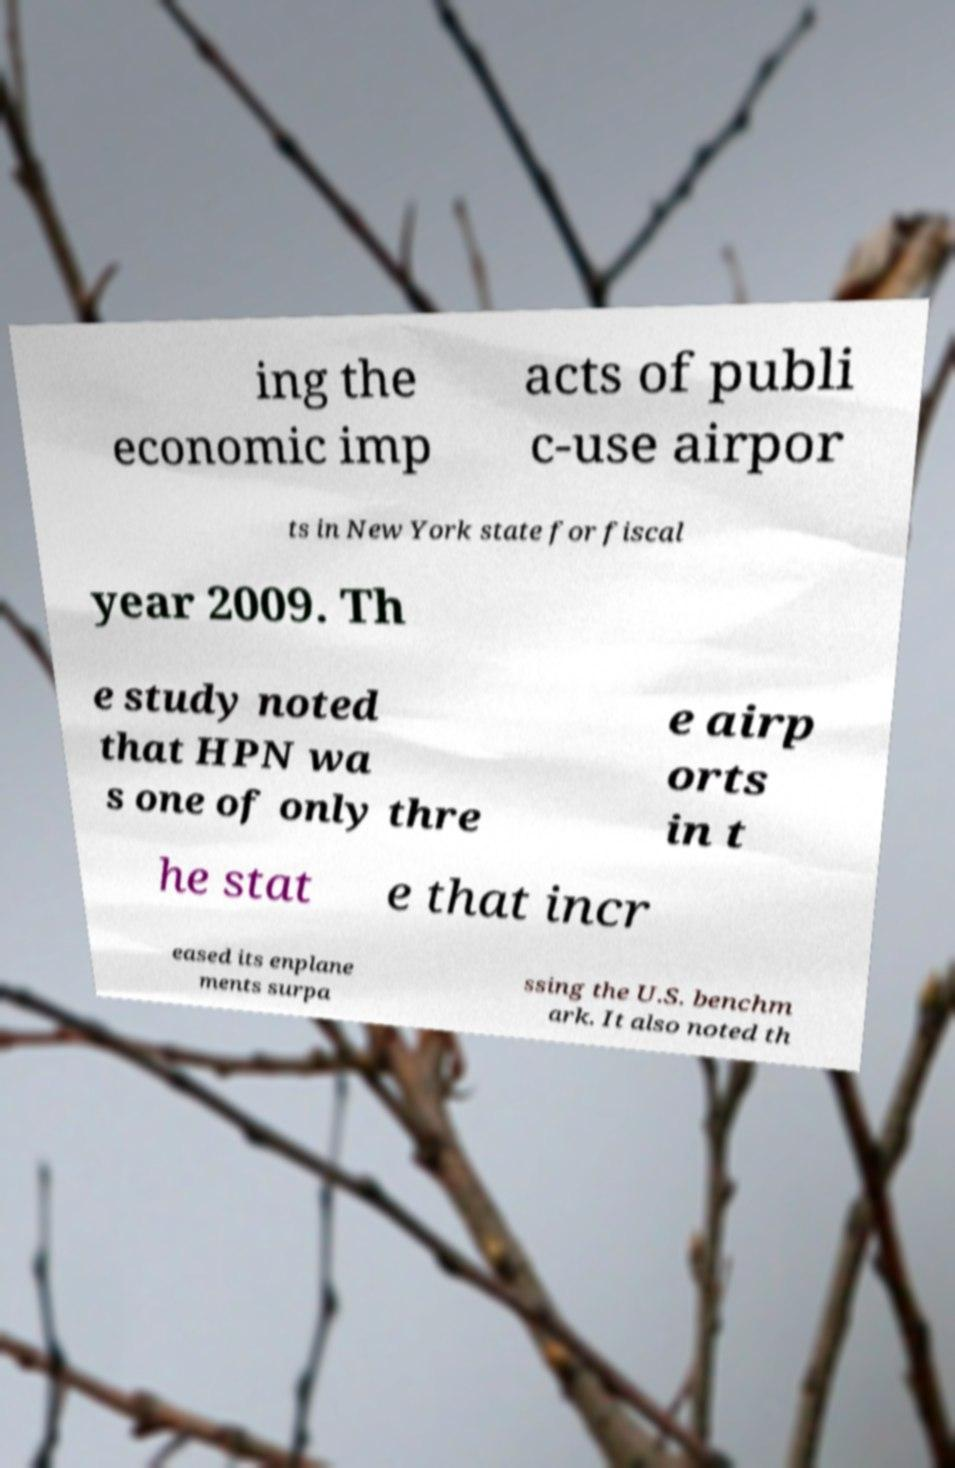There's text embedded in this image that I need extracted. Can you transcribe it verbatim? ing the economic imp acts of publi c-use airpor ts in New York state for fiscal year 2009. Th e study noted that HPN wa s one of only thre e airp orts in t he stat e that incr eased its enplane ments surpa ssing the U.S. benchm ark. It also noted th 